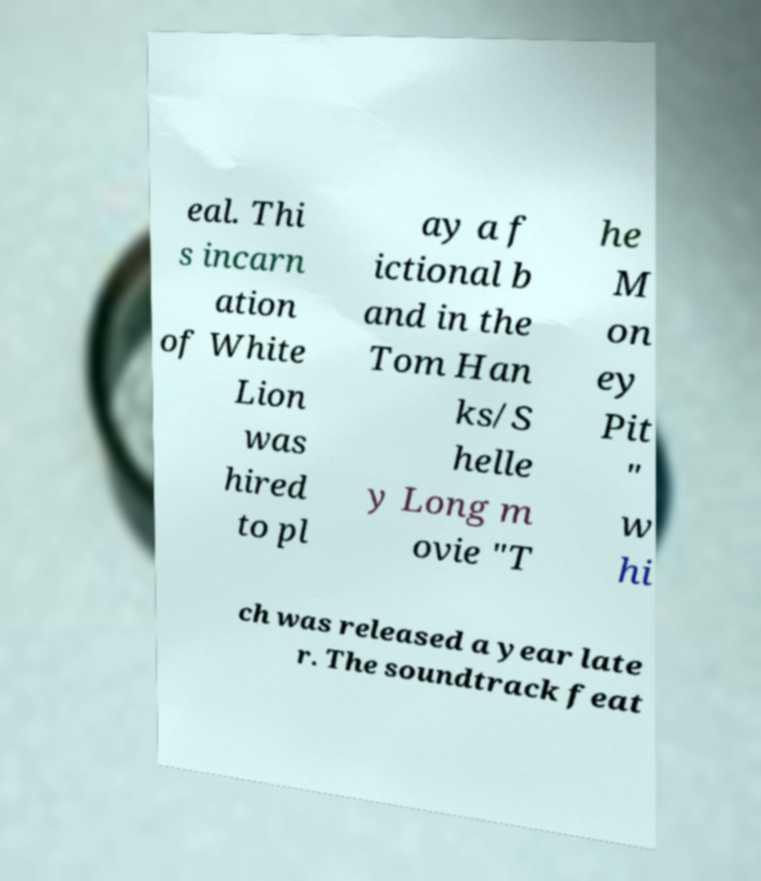There's text embedded in this image that I need extracted. Can you transcribe it verbatim? eal. Thi s incarn ation of White Lion was hired to pl ay a f ictional b and in the Tom Han ks/S helle y Long m ovie "T he M on ey Pit " w hi ch was released a year late r. The soundtrack feat 